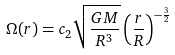<formula> <loc_0><loc_0><loc_500><loc_500>\Omega ( r ) = c _ { 2 } \sqrt { \frac { G M } { R ^ { 3 } } } \left ( \frac { r } { R } \right ) ^ { - \frac { 3 } { 2 } }</formula> 